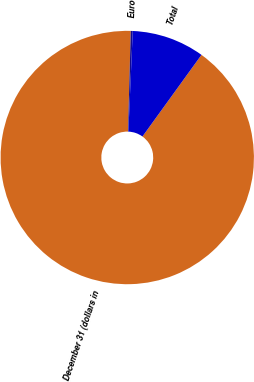Convert chart. <chart><loc_0><loc_0><loc_500><loc_500><pie_chart><fcel>December 31 (dollars in<fcel>Euro<fcel>Total<nl><fcel>90.48%<fcel>0.25%<fcel>9.27%<nl></chart> 